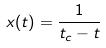<formula> <loc_0><loc_0><loc_500><loc_500>x ( t ) = \frac { 1 } { t _ { c } - t }</formula> 